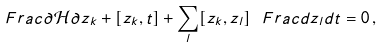Convert formula to latex. <formula><loc_0><loc_0><loc_500><loc_500>\ F r a c { \partial \mathcal { H } } { \partial z _ { k } } + [ z _ { k } , t ] + \sum _ { l } [ z _ { k } , z _ { l } ] \ F r a c { d z _ { l } } { d t } = 0 \, ,</formula> 